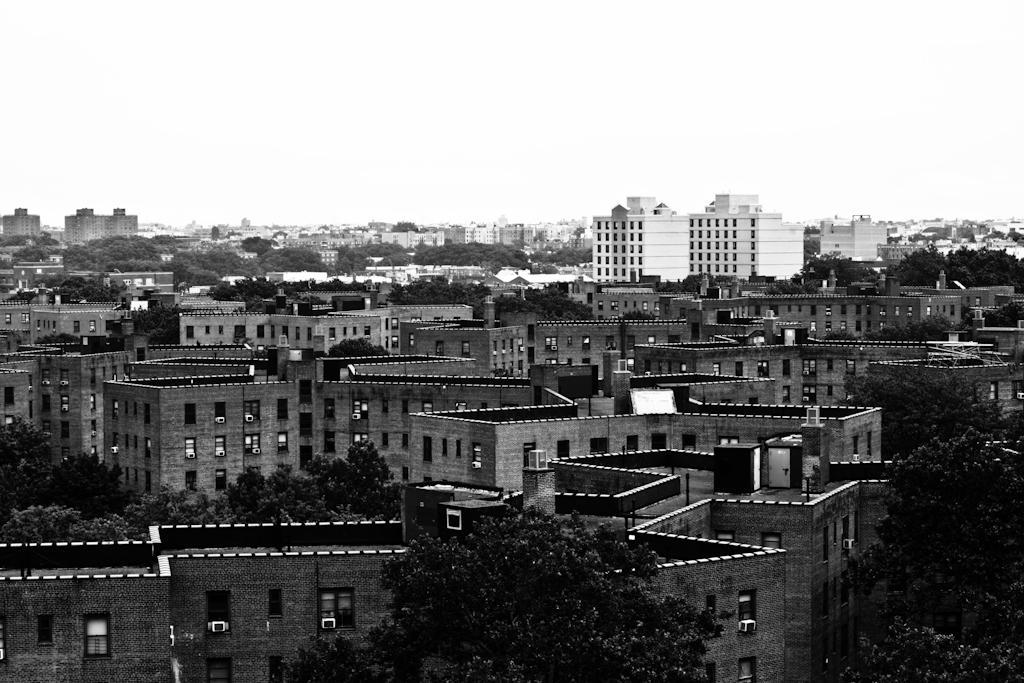Describe this image in one or two sentences. This is a black and white image. In this image there are many trees and buildings with windows and AC. In the background there is sky. 